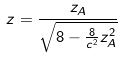Convert formula to latex. <formula><loc_0><loc_0><loc_500><loc_500>z = \frac { z _ { A } } { \sqrt { 8 - \frac { 8 } { c ^ { 2 } } z _ { A } ^ { 2 } } }</formula> 